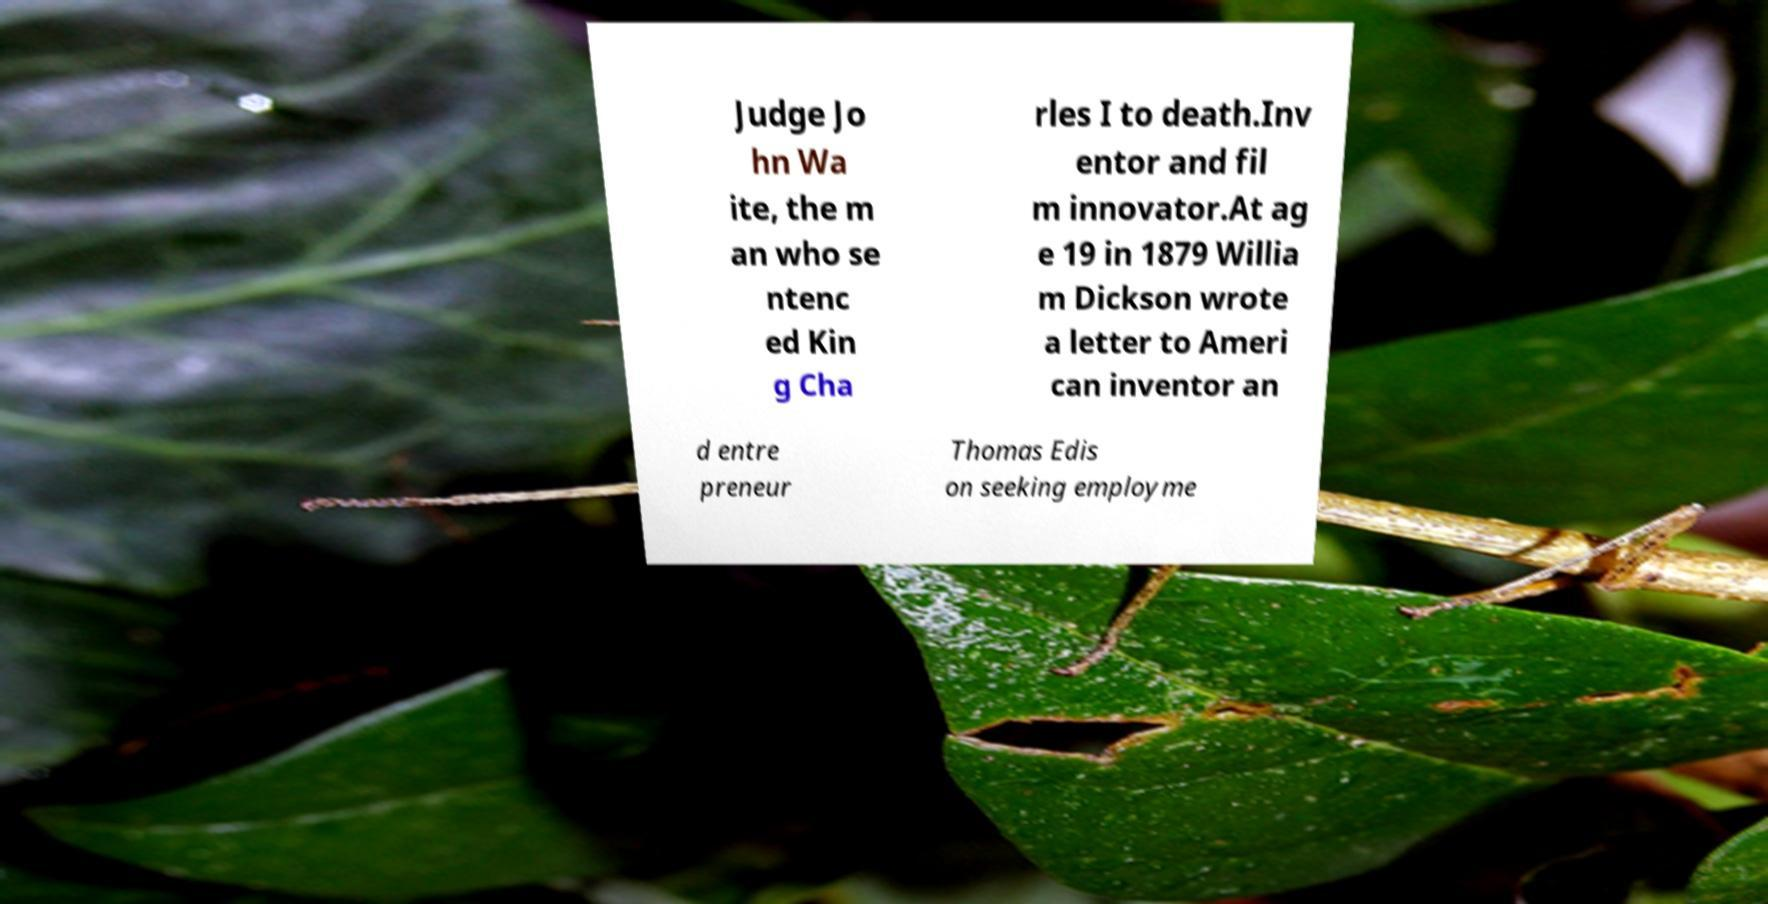There's text embedded in this image that I need extracted. Can you transcribe it verbatim? Judge Jo hn Wa ite, the m an who se ntenc ed Kin g Cha rles I to death.Inv entor and fil m innovator.At ag e 19 in 1879 Willia m Dickson wrote a letter to Ameri can inventor an d entre preneur Thomas Edis on seeking employme 